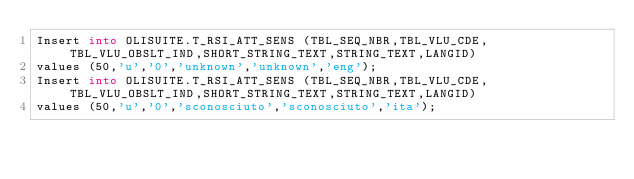Convert code to text. <code><loc_0><loc_0><loc_500><loc_500><_SQL_>Insert into OLISUITE.T_RSI_ATT_SENS (TBL_SEQ_NBR,TBL_VLU_CDE,TBL_VLU_OBSLT_IND,SHORT_STRING_TEXT,STRING_TEXT,LANGID) 
values (50,'u','0','unknown','unknown','eng');
Insert into OLISUITE.T_RSI_ATT_SENS (TBL_SEQ_NBR,TBL_VLU_CDE,TBL_VLU_OBSLT_IND,SHORT_STRING_TEXT,STRING_TEXT,LANGID) 
values (50,'u','0','sconosciuto','sconosciuto','ita');</code> 